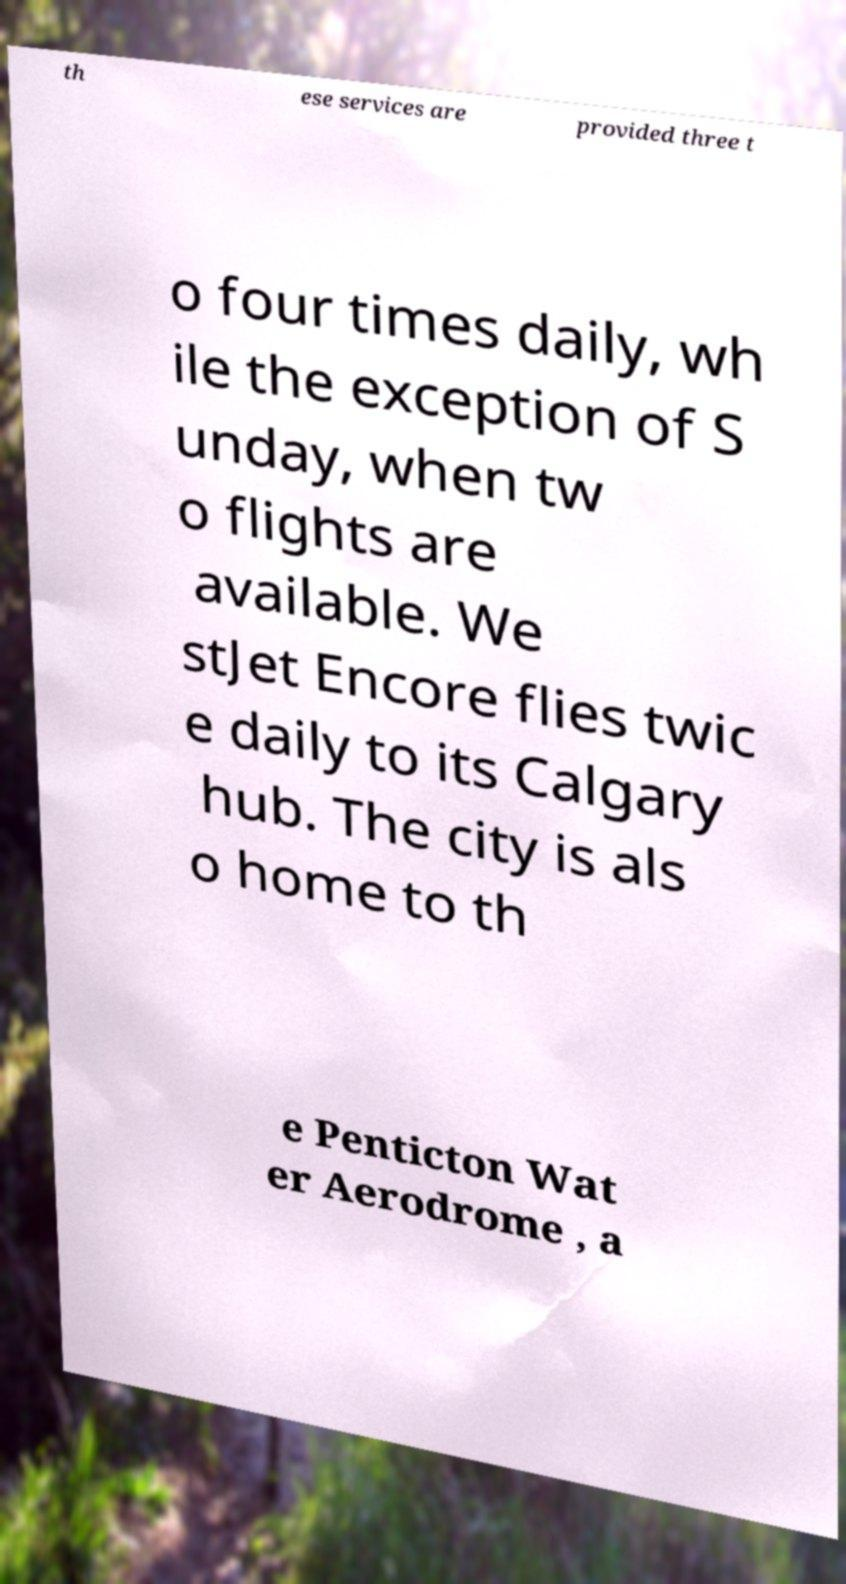Please identify and transcribe the text found in this image. th ese services are provided three t o four times daily, wh ile the exception of S unday, when tw o flights are available. We stJet Encore flies twic e daily to its Calgary hub. The city is als o home to th e Penticton Wat er Aerodrome , a 